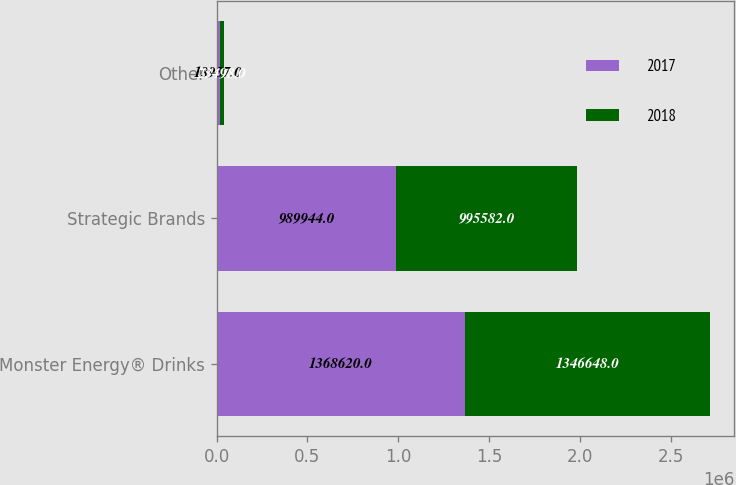Convert chart. <chart><loc_0><loc_0><loc_500><loc_500><stacked_bar_chart><ecel><fcel>Monster Energy® Drinks<fcel>Strategic Brands<fcel>Other<nl><fcel>2017<fcel>1.36862e+06<fcel>989944<fcel>18957<nl><fcel>2018<fcel>1.34665e+06<fcel>995582<fcel>23498<nl></chart> 